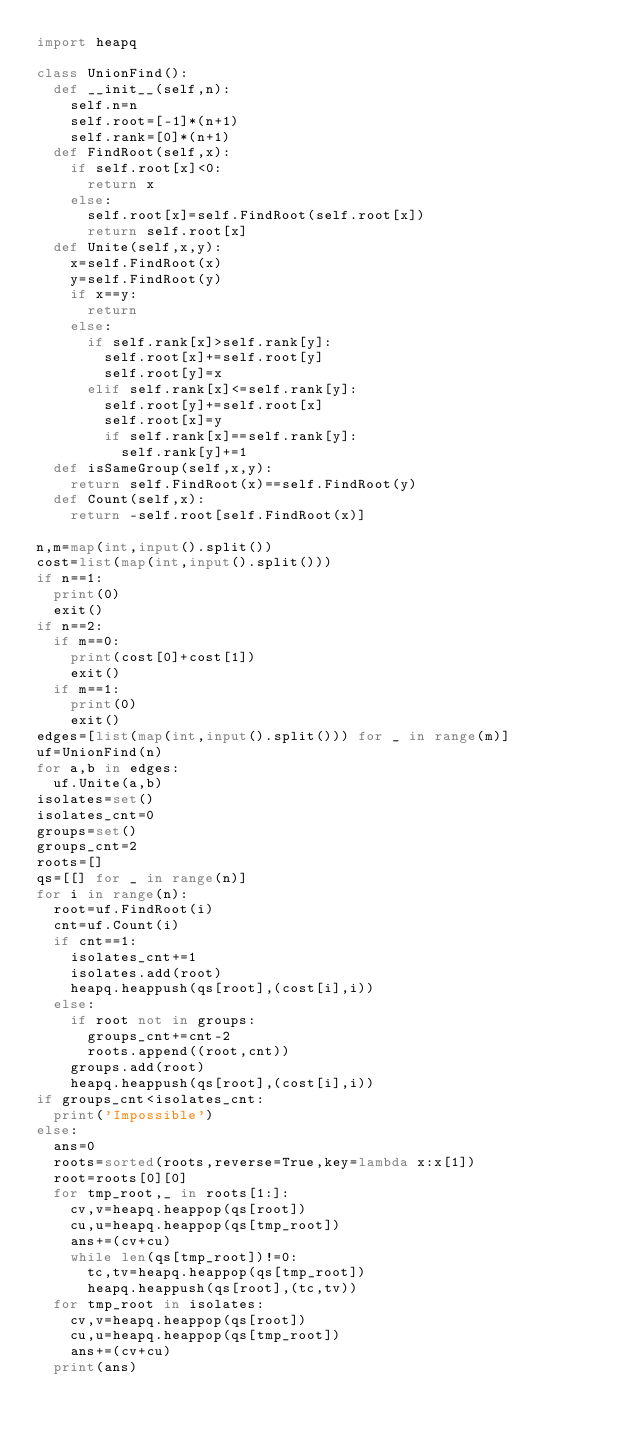<code> <loc_0><loc_0><loc_500><loc_500><_Python_>import heapq

class UnionFind():
  def __init__(self,n):
    self.n=n
    self.root=[-1]*(n+1)
    self.rank=[0]*(n+1)
  def FindRoot(self,x):
    if self.root[x]<0:
      return x
    else:
      self.root[x]=self.FindRoot(self.root[x])
      return self.root[x]
  def Unite(self,x,y):
    x=self.FindRoot(x)
    y=self.FindRoot(y)
    if x==y:
      return
    else:
      if self.rank[x]>self.rank[y]:
        self.root[x]+=self.root[y]
        self.root[y]=x
      elif self.rank[x]<=self.rank[y]:
        self.root[y]+=self.root[x]
        self.root[x]=y
        if self.rank[x]==self.rank[y]:
          self.rank[y]+=1
  def isSameGroup(self,x,y):
    return self.FindRoot(x)==self.FindRoot(y)
  def Count(self,x):
    return -self.root[self.FindRoot(x)]

n,m=map(int,input().split())
cost=list(map(int,input().split()))
if n==1:
  print(0)
  exit()
if n==2:
  if m==0:
    print(cost[0]+cost[1])
    exit()
  if m==1:
    print(0)
    exit()
edges=[list(map(int,input().split())) for _ in range(m)]
uf=UnionFind(n)
for a,b in edges:
  uf.Unite(a,b)
isolates=set()
isolates_cnt=0
groups=set()
groups_cnt=2
roots=[]
qs=[[] for _ in range(n)]
for i in range(n):
  root=uf.FindRoot(i)
  cnt=uf.Count(i)
  if cnt==1:
    isolates_cnt+=1
    isolates.add(root)
    heapq.heappush(qs[root],(cost[i],i))
  else:
    if root not in groups:
      groups_cnt+=cnt-2
      roots.append((root,cnt))
    groups.add(root)
    heapq.heappush(qs[root],(cost[i],i))
if groups_cnt<isolates_cnt:
  print('Impossible')
else:
  ans=0
  roots=sorted(roots,reverse=True,key=lambda x:x[1])
  root=roots[0][0]
  for tmp_root,_ in roots[1:]:
    cv,v=heapq.heappop(qs[root])
    cu,u=heapq.heappop(qs[tmp_root])
    ans+=(cv+cu)
    while len(qs[tmp_root])!=0:
      tc,tv=heapq.heappop(qs[tmp_root])
      heapq.heappush(qs[root],(tc,tv))
  for tmp_root in isolates:
    cv,v=heapq.heappop(qs[root])
    cu,u=heapq.heappop(qs[tmp_root])
    ans+=(cv+cu)
  print(ans)</code> 